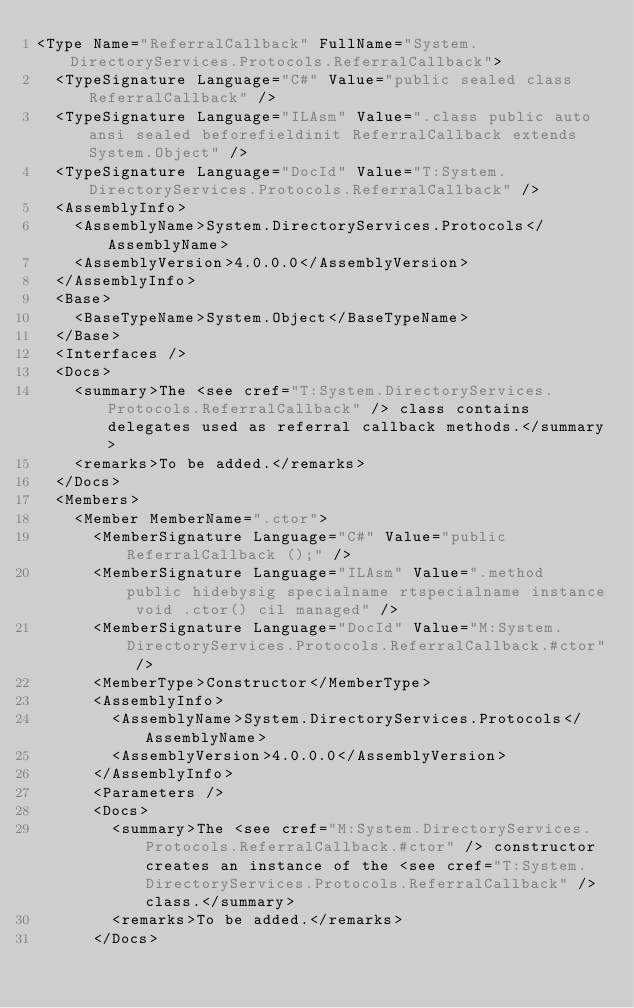Convert code to text. <code><loc_0><loc_0><loc_500><loc_500><_XML_><Type Name="ReferralCallback" FullName="System.DirectoryServices.Protocols.ReferralCallback">
  <TypeSignature Language="C#" Value="public sealed class ReferralCallback" />
  <TypeSignature Language="ILAsm" Value=".class public auto ansi sealed beforefieldinit ReferralCallback extends System.Object" />
  <TypeSignature Language="DocId" Value="T:System.DirectoryServices.Protocols.ReferralCallback" />
  <AssemblyInfo>
    <AssemblyName>System.DirectoryServices.Protocols</AssemblyName>
    <AssemblyVersion>4.0.0.0</AssemblyVersion>
  </AssemblyInfo>
  <Base>
    <BaseTypeName>System.Object</BaseTypeName>
  </Base>
  <Interfaces />
  <Docs>
    <summary>The <see cref="T:System.DirectoryServices.Protocols.ReferralCallback" /> class contains delegates used as referral callback methods.</summary>
    <remarks>To be added.</remarks>
  </Docs>
  <Members>
    <Member MemberName=".ctor">
      <MemberSignature Language="C#" Value="public ReferralCallback ();" />
      <MemberSignature Language="ILAsm" Value=".method public hidebysig specialname rtspecialname instance void .ctor() cil managed" />
      <MemberSignature Language="DocId" Value="M:System.DirectoryServices.Protocols.ReferralCallback.#ctor" />
      <MemberType>Constructor</MemberType>
      <AssemblyInfo>
        <AssemblyName>System.DirectoryServices.Protocols</AssemblyName>
        <AssemblyVersion>4.0.0.0</AssemblyVersion>
      </AssemblyInfo>
      <Parameters />
      <Docs>
        <summary>The <see cref="M:System.DirectoryServices.Protocols.ReferralCallback.#ctor" /> constructor creates an instance of the <see cref="T:System.DirectoryServices.Protocols.ReferralCallback" /> class.</summary>
        <remarks>To be added.</remarks>
      </Docs></code> 